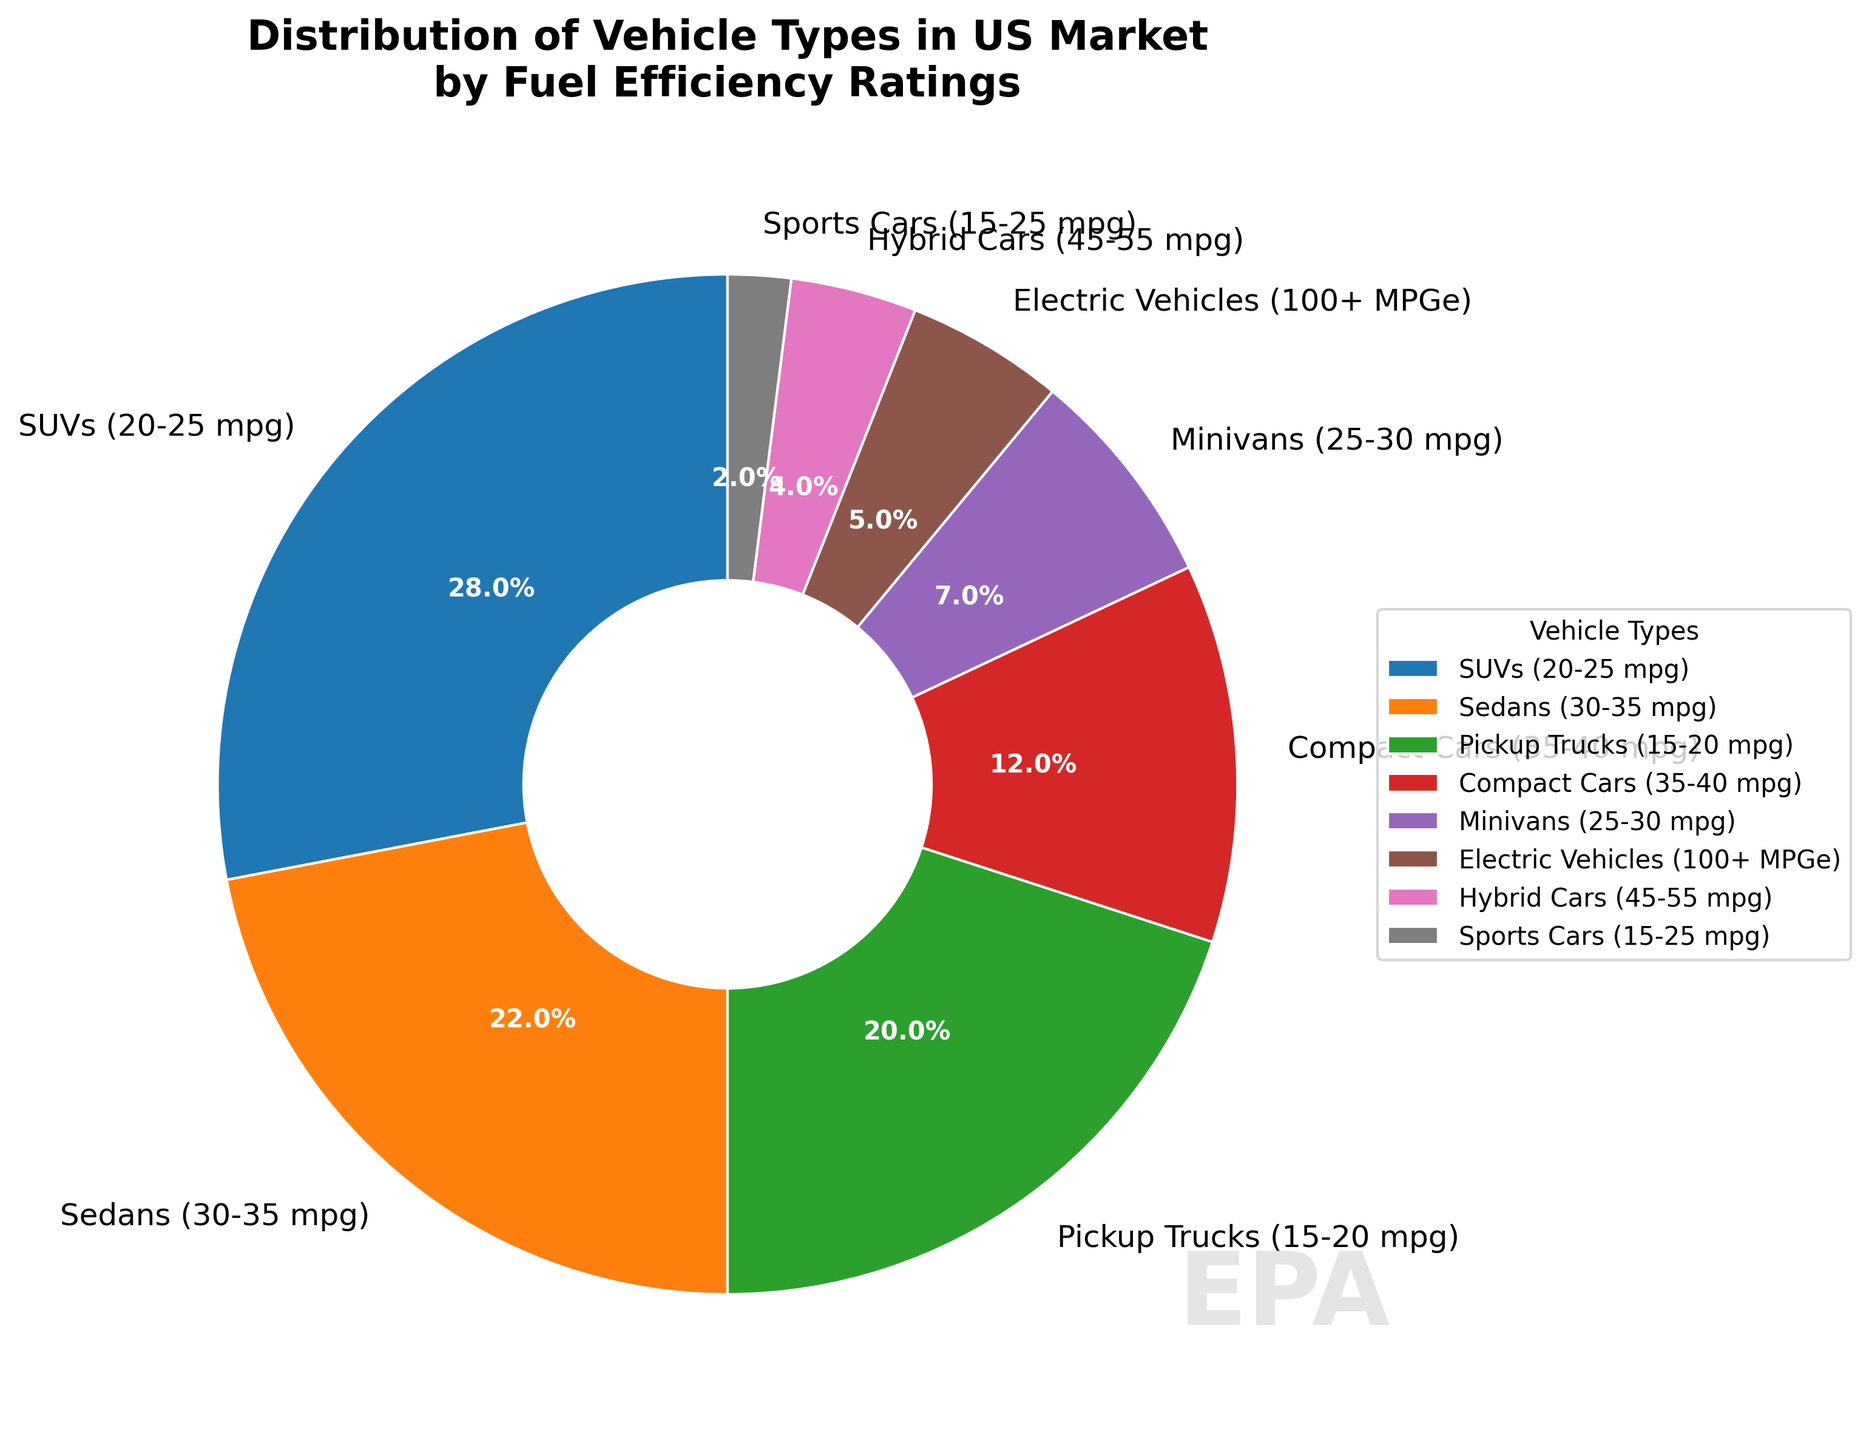What's the largest vehicle category by percentage? Observing the pie chart, SUVs (20-25 mpg) section is the largest which is labeled with a percentage of 28%
Answer: SUVs (20-25 mpg) Which category represents the smallest percentage? Checking the chart, Sports Cars (15-25 mpg) segment with a label of 2% is the smallest
Answer: Sports Cars (15-25 mpg) How much more is the percentage of SUVs compared to Hybrids? The difference between the percentages is calculated as: 28% (SUVs) - 4% (Hybrid Cars) = 24%
Answer: 24% Do the combined percentages of Sedans and Pickup Trucks exceed 40%? Summing the percentages of Sedans (22%) and Pickup Trucks (20%) results in 42%, which is greater than 40%
Answer: Yes Which category is represented in red? Observing the figure, red color is used for Pickup Trucks (15-20 mpg)
Answer: Pickup Trucks (15-20 mpg) How many categories have a percentage less than 10%? The sections representing Minivans (7%), Electric Vehicles (5%), Hybrid Cars (4%), and Sports Cars (2%) are less than 10%. Counting them, there are 4 categories
Answer: 4 Are Electric Vehicles and Compact Cars combined percentage greater than that of SUVs? Combining Electric Vehicles (5%) and Compact Cars (12%) results in 17%, which is less than SUVs' 28%
Answer: No Does the combined percentage of Electric Vehicles, Hybrid Cars, and Sports Cars equal that of Pickup Trucks? Summing Electric Vehicles (5%), Hybrid Cars (4%), and Sports Cars (2%) gives 11%, which is less than Pickup Trucks' 20%
Answer: No Which category falls under the cyan color? Observing the pie chart, cyan color represents Compact Cars (35-40 mpg)
Answer: Compact Cars (35-40 mpg) What is the combined percentage of the vehicle types having fuel efficiencies of 30-35 mpg and 45-55 mpg? Adding Sedans (30-35 mpg) with 22% and Hybrid Cars (45-55 mpg) with 4% results in a total of 26%
Answer: 26% 